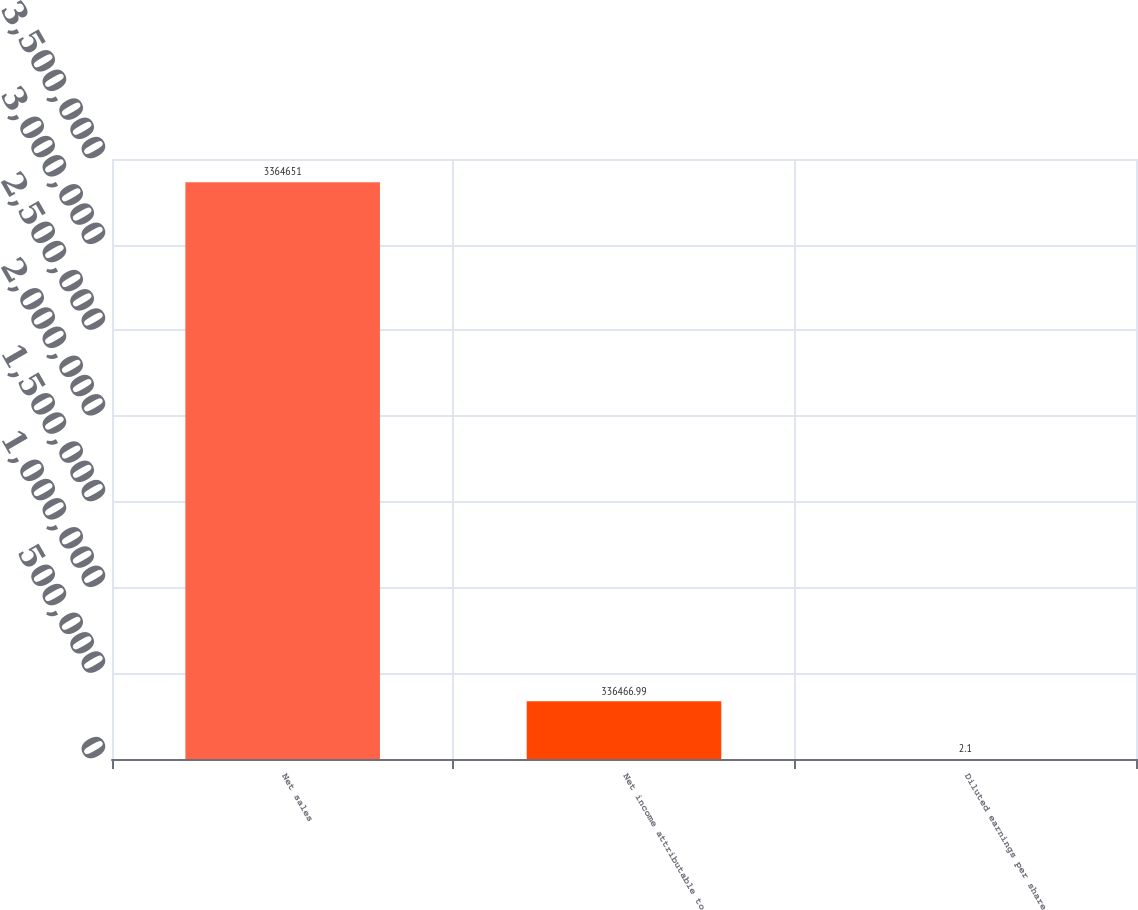Convert chart. <chart><loc_0><loc_0><loc_500><loc_500><bar_chart><fcel>Net sales<fcel>Net income attributable to<fcel>Diluted earnings per share<nl><fcel>3.36465e+06<fcel>336467<fcel>2.1<nl></chart> 